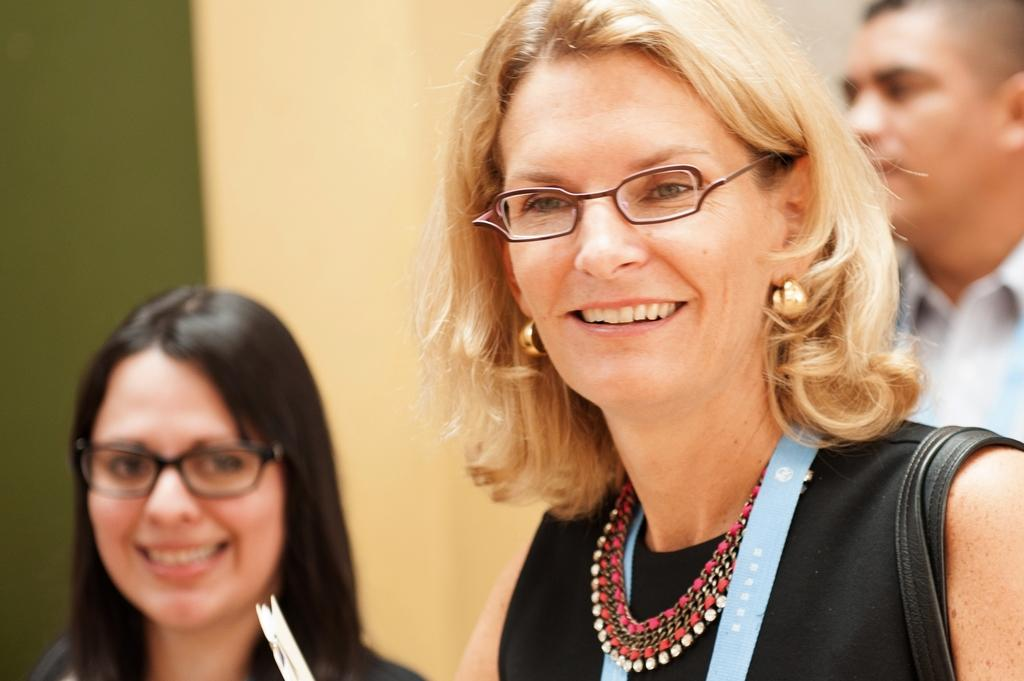How many people are present in the image? There are three persons in the image. What can be seen in the background of the image? There is a wall in the background of the image. What type of train is passing by in the image? There is no train present in the image; it only features three persons and a wall in the background. 